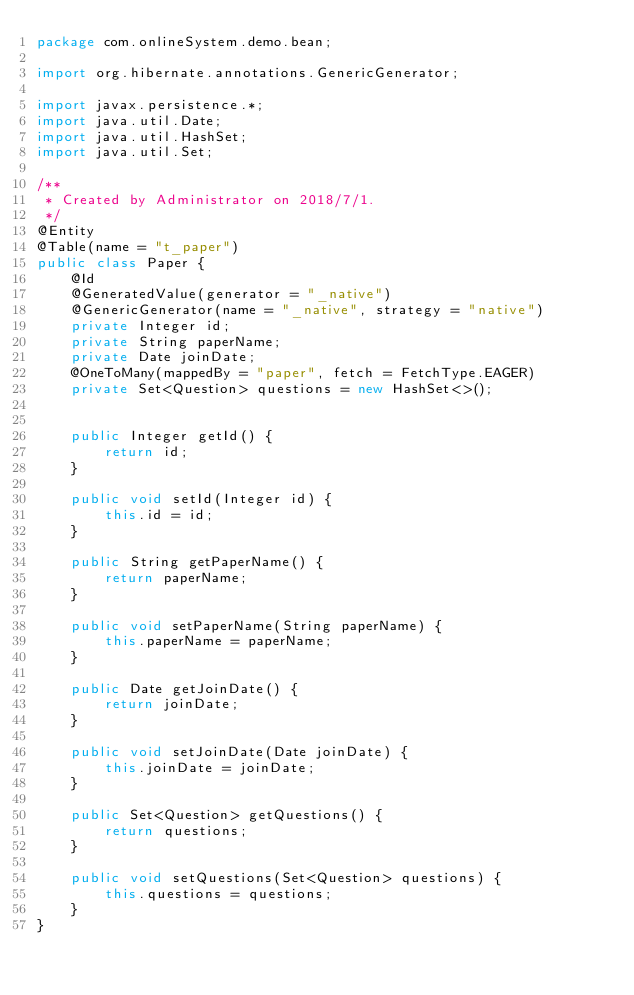Convert code to text. <code><loc_0><loc_0><loc_500><loc_500><_Java_>package com.onlineSystem.demo.bean;

import org.hibernate.annotations.GenericGenerator;

import javax.persistence.*;
import java.util.Date;
import java.util.HashSet;
import java.util.Set;

/**
 * Created by Administrator on 2018/7/1.
 */
@Entity
@Table(name = "t_paper")
public class Paper {
    @Id
    @GeneratedValue(generator = "_native")
    @GenericGenerator(name = "_native", strategy = "native")
    private Integer id;
    private String paperName;
    private Date joinDate;
    @OneToMany(mappedBy = "paper", fetch = FetchType.EAGER)
    private Set<Question> questions = new HashSet<>();


    public Integer getId() {
        return id;
    }

    public void setId(Integer id) {
        this.id = id;
    }

    public String getPaperName() {
        return paperName;
    }

    public void setPaperName(String paperName) {
        this.paperName = paperName;
    }

    public Date getJoinDate() {
        return joinDate;
    }

    public void setJoinDate(Date joinDate) {
        this.joinDate = joinDate;
    }

    public Set<Question> getQuestions() {
        return questions;
    }

    public void setQuestions(Set<Question> questions) {
        this.questions = questions;
    }
}
</code> 